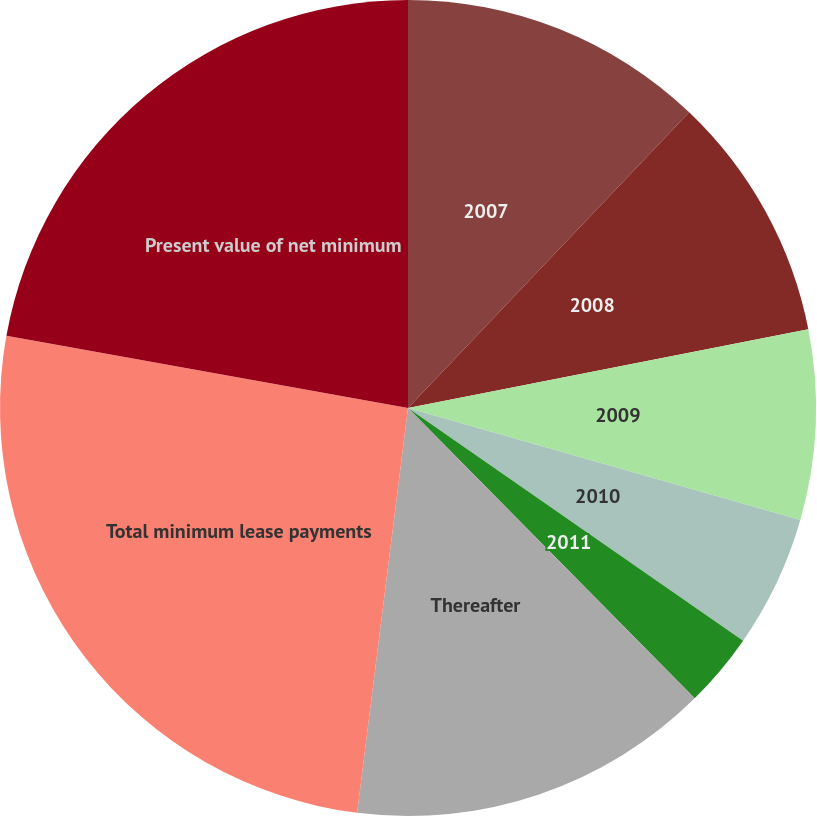Convert chart. <chart><loc_0><loc_0><loc_500><loc_500><pie_chart><fcel>2007<fcel>2008<fcel>2009<fcel>2010<fcel>2011<fcel>Thereafter<fcel>Total minimum lease payments<fcel>Present value of net minimum<nl><fcel>12.1%<fcel>9.81%<fcel>7.52%<fcel>5.23%<fcel>2.94%<fcel>14.39%<fcel>25.84%<fcel>22.17%<nl></chart> 